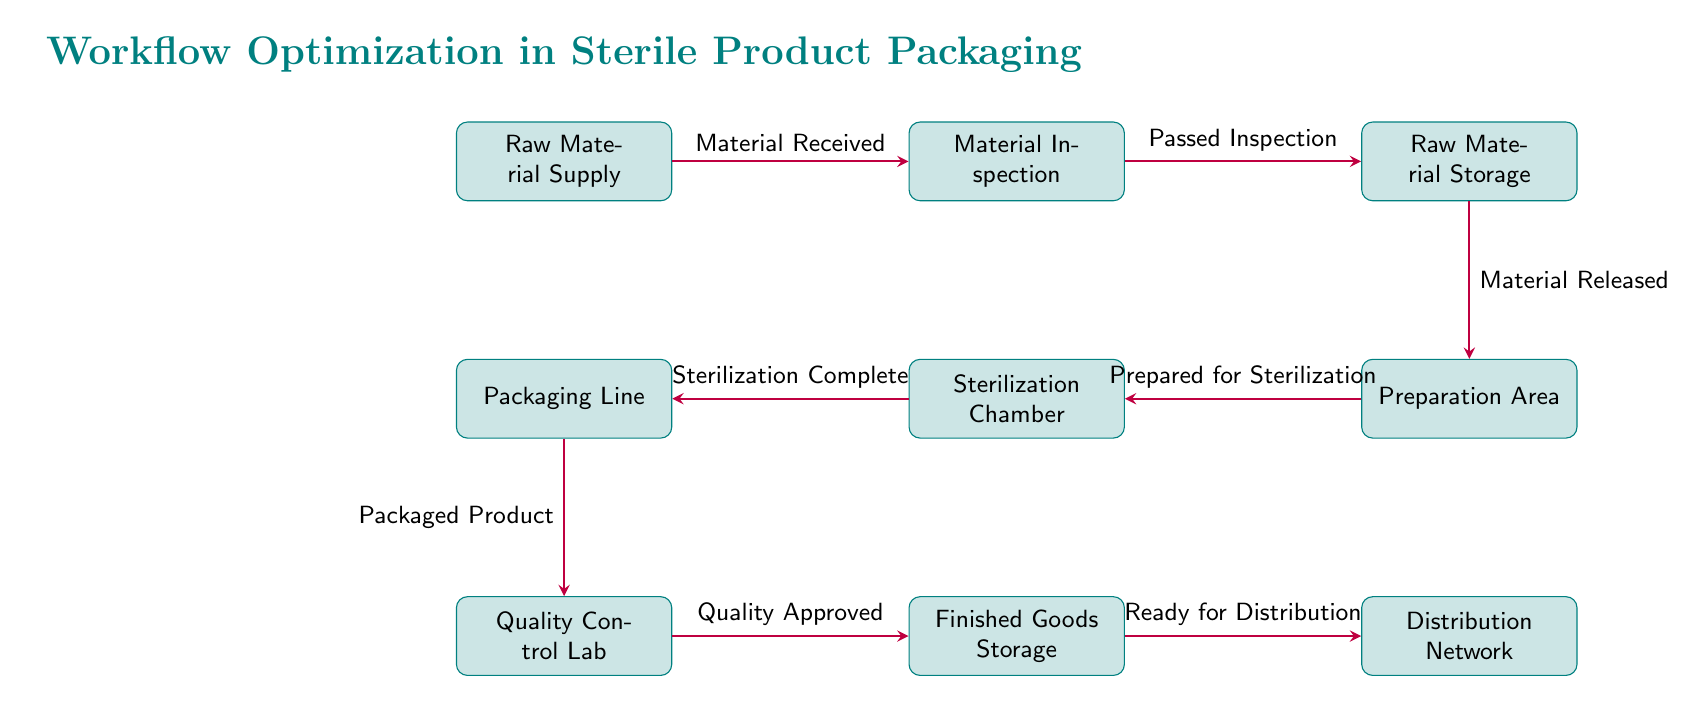What is the first step in the workflow? The first step in the workflow, as shown in the diagram, is the "Raw Material Supply." This is indicated as the starting node at the leftmost position.
Answer: Raw Material Supply How many processes are involved in the workflow? The diagram contains a total of 8 processes, identified as distinct nodes, listed sequentially from "Raw Material Supply" through to "Distribution Network."
Answer: 8 What happens after the material inspection? After the material inspection, if the material has "Passed Inspection," it moves to "Raw Material Storage" as the next step in the workflow. This is shown by the directed arrow from "Material Inspection" to "Raw Material Storage."
Answer: Raw Material Storage Which process comes directly after the sterilization chamber? The process that comes directly after the "Sterilization Chamber" in the workflow is the "Packaging Line," as indicated by the arrow leading from "Sterilization Chamber" to "Packaging Line."
Answer: Packaging Line What is the result of the quality control lab process? The result of the quality control lab process is "Quality Approved," leading to the next node "Finished Goods Storage." This is specified by the label on the arrow connecting these two nodes.
Answer: Quality Approved What is the last step before distribution? The last step before distribution is the "Finished Goods Storage," which is the penultimate node before the final node labeled "Distribution Network." This node signifies that the products are ready prior to distribution.
Answer: Finished Goods Storage Which process requires sterilization? The process that requires sterilization is the "Preparation Area," as indicated by the arrow leading into the "Sterilization Chamber" that specifies the input for sterilization.
Answer: Preparation Area What checks the quality of the packaged product? The "Quality Control Lab" checks the quality of the packaged product, as indicated by its position in the workflow following the "Packaging Line."
Answer: Quality Control Lab 